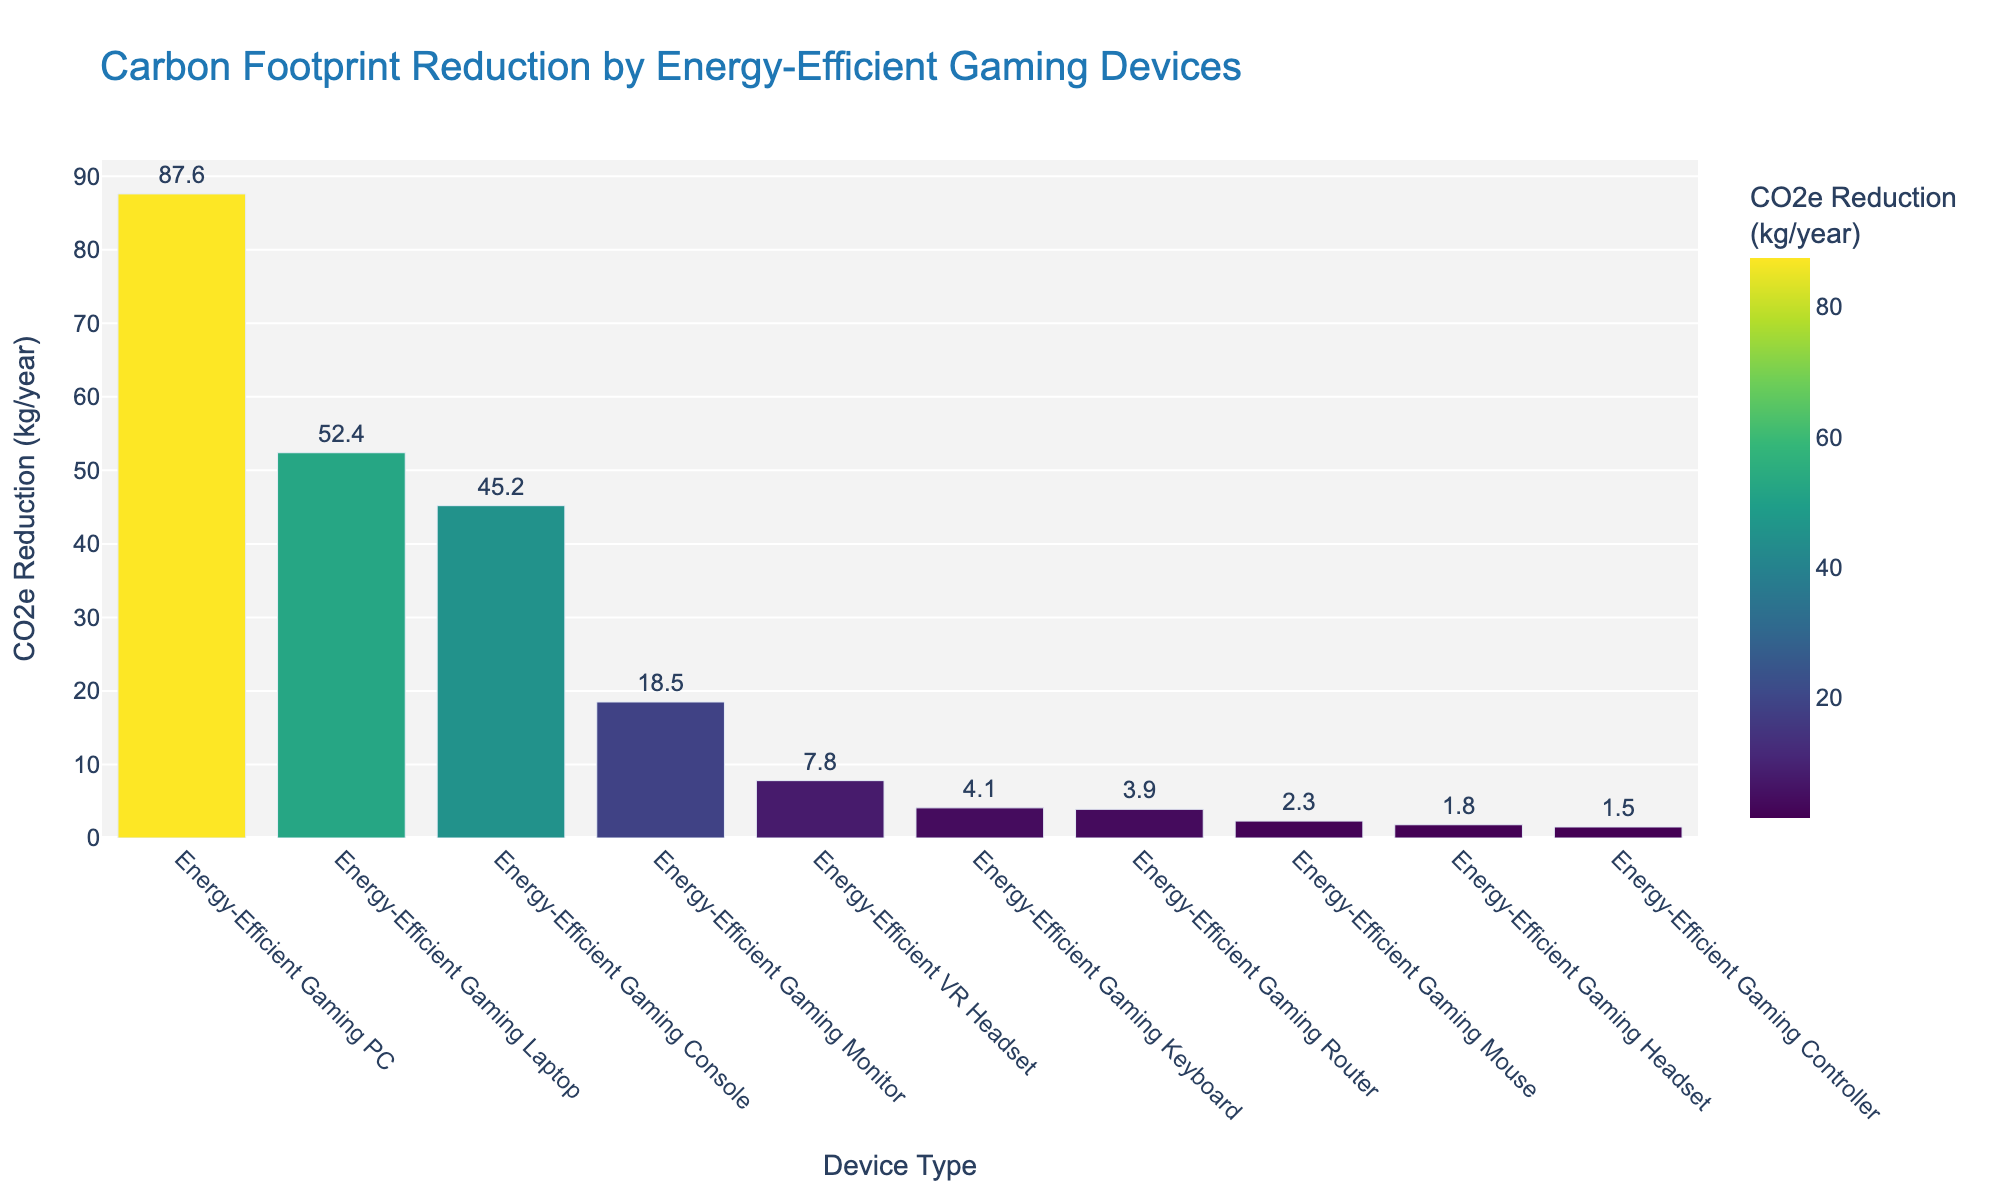What's the device with the highest carbon footprint reduction? The bar chart shows the carbon footprint reduction for each device, and the Energy-Efficient Gaming PC has the tallest bar, indicating it has the highest reduction.
Answer: Energy-Efficient Gaming PC How much more CO2e does the energy-efficient gaming PC reduce compared to the energy-efficient gaming laptop? The Energy-Efficient Gaming PC reduces 87.6 kg CO2e/year, while the Energy-Efficient Gaming Laptop reduces 52.4 kg CO2e/year. The difference is 87.6 - 52.4 = 35.2 kg CO2e/year.
Answer: 35.2 kg CO2e/year What's the total carbon footprint reduction achieved by the Energy-Efficient Gaming Monitor, Router, and Headset combined? The reductions are 18.5 kg CO2e/year (Gaming Monitor), 3.9 kg CO2e/year (Gaming Router), and 1.8 kg CO2e/year (Gaming Headset). Summing these up, 18.5 + 3.9 + 1.8 = 24.2 kg CO2e/year.
Answer: 24.2 kg CO2e/year Which device type has the second highest CO2e reduction, and by how much does it exceed the reduction of the Energy-Efficient Gaming Console? The Energy-Efficient Gaming Laptop has the second highest reduction (52.4 kg CO2e/year). The Energy-Efficient Gaming Console reduces 45.2 kg CO2e/year. The excess reduction is 52.4 - 45.2 = 7.2 kg CO2e/year.
Answer: Energy-Efficient Gaming Laptop, 7.2 kg CO2e/year Is the carbon footprint reduction of the Energy-Efficient VR Headset greater than that of the Energy-Efficient Gaming Router? If so, by how much? The Energy-Efficient VR Headset reduces 7.8 kg CO2e/year, and the Energy-Efficient Gaming Router reduces 3.9 kg CO2e/year. The difference is 7.8 - 3.9 = 3.9 kg CO2e/year.
Answer: Yes, by 3.9 kg CO2e/year What is the average carbon footprint reduction of the top three devices? The top three devices are the Energy-Efficient Gaming PC (87.6 kg CO2e/year), the Gaming Laptop (52.4 kg CO2e/year), and the Gaming Console (45.2 kg CO2e/year). Summing these up, 87.6 + 52.4 + 45.2 = 185.2, and the average is 185.2 / 3 = 61.73 kg CO2e/year.
Answer: 61.73 kg CO2e/year How many devices achieve a carbon footprint reduction greater than 20 kg CO2e/year? The Energy-Efficient Gaming PC (87.6 kg CO2e/year), Gaming Laptop (52.4 kg CO2e/year), Gaming Console (45.2 kg CO2e/year), and Gaming Monitor (18.5 kg CO2e/year; not considered as it's less than 20 kg) are the only devices listed.
Answer: 3 devices 